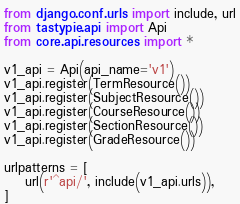Convert code to text. <code><loc_0><loc_0><loc_500><loc_500><_Python_>from django.conf.urls import include, url
from tastypie.api import Api
from core.api.resources import *

v1_api = Api(api_name='v1')
v1_api.register(TermResource())
v1_api.register(SubjectResource())
v1_api.register(CourseResource())
v1_api.register(SectionResource())
v1_api.register(GradeResource())

urlpatterns = [
    url(r'^api/', include(v1_api.urls)),
]
</code> 